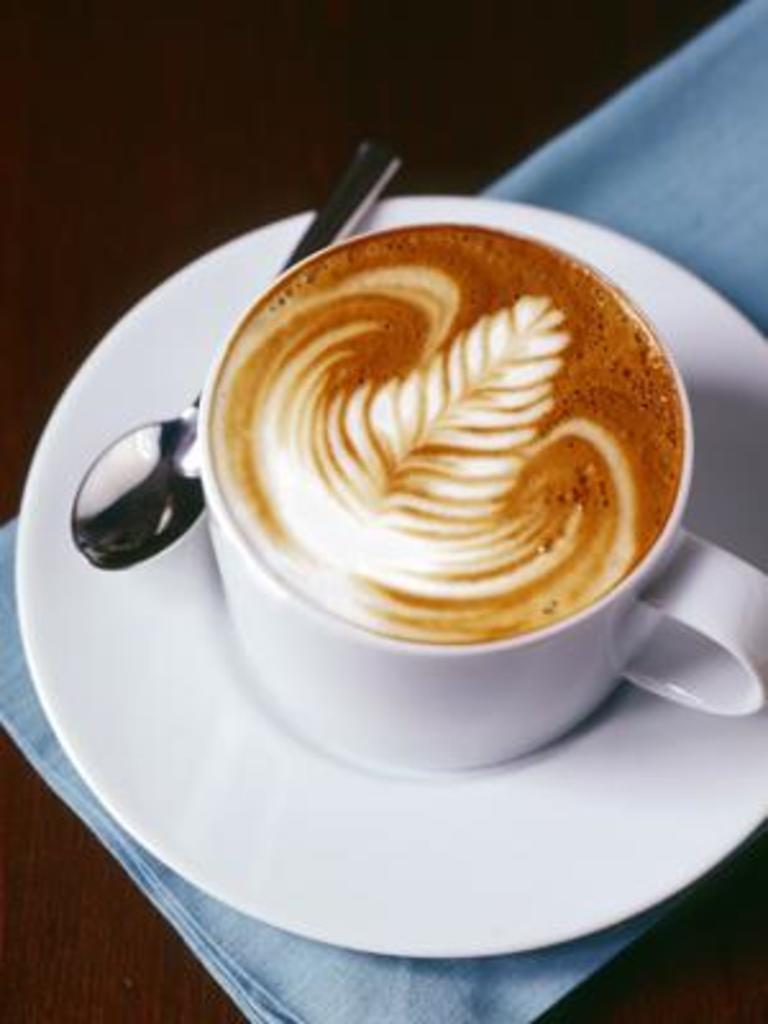Describe this image in one or two sentences. This picture shows a coffee cup and a saucer with spoon and we see a cloth on the table. 